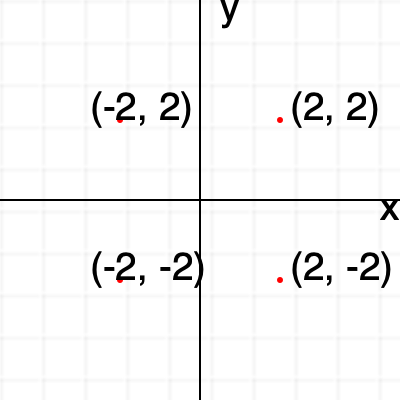Plot the points $(-2, 2)$, $(2, 2)$, $(2, -2)$, and $(-2, -2)$ on the coordinate plane. What shape do these points form when connected? Let's follow these steps:

1. Understand the coordinate plane:
   - The horizontal axis is the x-axis
   - The vertical axis is the y-axis
   - The point where they intersect is the origin (0, 0)

2. Plot the points:
   - $(-2, 2)$: Move 2 units left and 2 units up from the origin
   - $(2, 2)$: Move 2 units right and 2 units up from the origin
   - $(2, -2)$: Move 2 units right and 2 units down from the origin
   - $(-2, -2)$: Move 2 units left and 2 units down from the origin

3. Connect the points:
   - When you connect these points in order, you'll see they form a square

4. Verify the shape:
   - All sides are equal in length (4 units)
   - All angles are 90 degrees (right angles)

Therefore, the shape formed by connecting these points is a square.
Answer: Square 